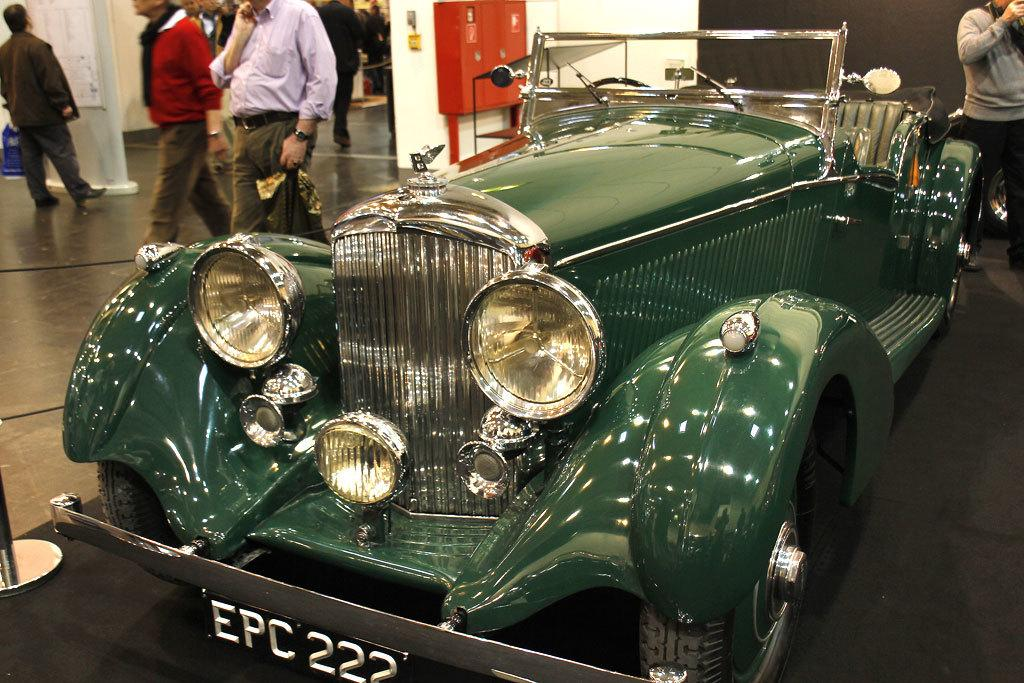What is the main subject in the image? There is a vehicle in the image. What else can be seen on the ground in the image? There are people on the floor in the image. What object is present in the image that might be used for displaying information or messages? There is a board in the image. What other object can be seen in the image that might be used for storage? There is a box in the image. What type of structure is visible in the background of the image? There is a wall in the image. What type of authority figure can be seen in the image? There is no authority figure present in the image. Who are the friends of the people on the floor in the image? The provided facts do not mention any friends, so we cannot determine who their friends are from the image. 